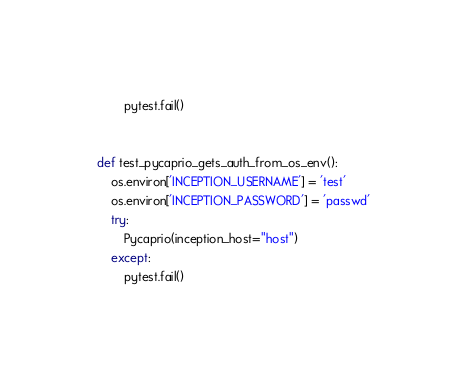<code> <loc_0><loc_0><loc_500><loc_500><_Python_>        pytest.fail()


def test_pycaprio_gets_auth_from_os_env():
    os.environ['INCEPTION_USERNAME'] = 'test'
    os.environ['INCEPTION_PASSWORD'] = 'passwd'
    try:
        Pycaprio(inception_host="host")
    except:
        pytest.fail()
</code> 